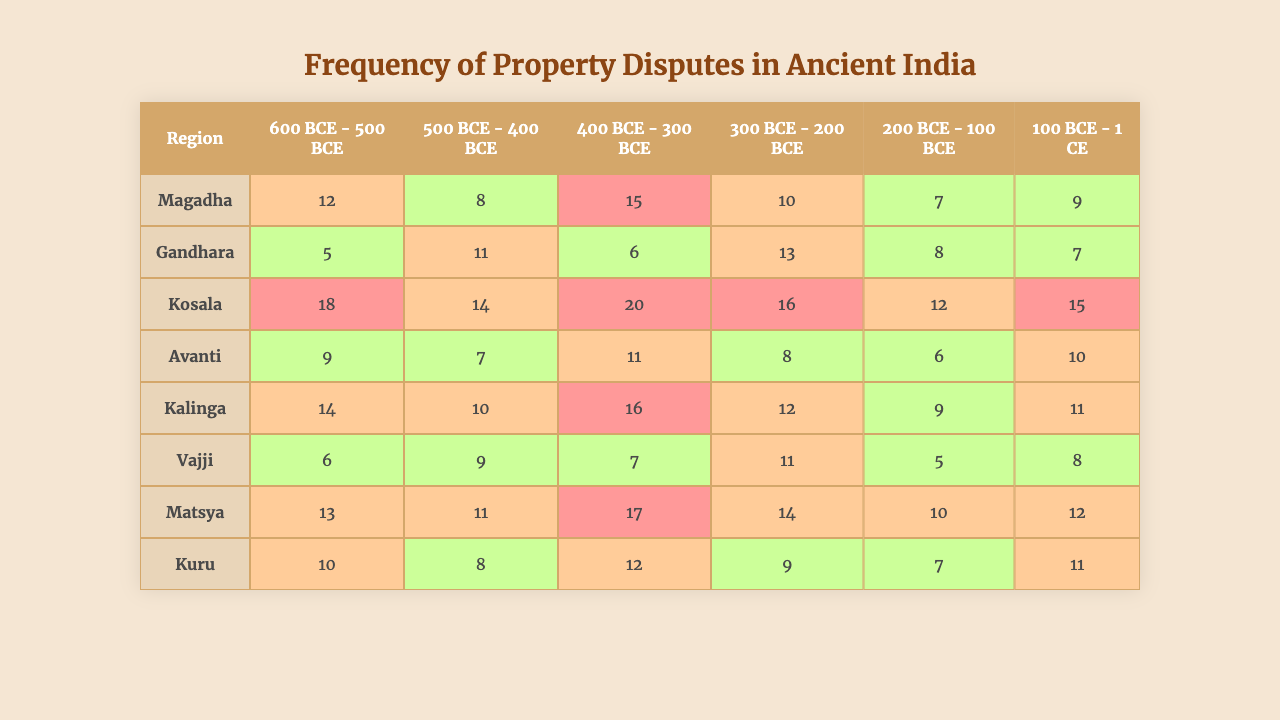What region had the highest property dispute frequency in the time period of 600 BCE - 500 BCE? In the time period of 600 BCE - 500 BCE, the dispute frequency for each region is as follows: Magadha (12), Gandhara (5), Kosala (18), Avanti (9), Kalinga (14), Vajji (6), Matsya (13), Kuru (10). The highest frequency is in Kosala with 18 disputes.
Answer: Kosala What was the average frequency of property disputes across all regions during the time period of 100 BCE - 1 CE? The frequencies in the 100 BCE - 1 CE period for all regions are: Magadha (9), Gandhara (7), Kosala (15), Avanti (10), Kalinga (11), Vajji (8), Matsya (12), and Kuru (11). The total is 9 + 7 + 15 + 10 + 11 + 8 + 12 + 11 = 83, and there are 8 regions, so the average is 83/8 = 10.375.
Answer: 10.375 In which time period did Avanti experience the lowest property dispute frequency? The frequencies for Avanti across the time periods are: 10 (600-500 BCE), 13 (500-400 BCE), 8 (400-300 BCE), 7 (300-200 BCE), 6 (200-100 BCE), and 10 (100 BCE-1 CE). The lowest frequency is 6, which occurred in the time period of 200 BCE - 100 BCE.
Answer: 200 BCE - 100 BCE Did Kosala have a higher dispute frequency than Magadha in the 400 BCE - 300 BCE period? The dispute frequency for Kosala in the 400 BCE - 300 BCE period is 20, while for Magadha it is 15. Since 20 is greater than 15, Kosala did indeed have a higher frequency than Magadha.
Answer: Yes Which region had a consistent increase in dispute frequency over consecutive time periods? By analyzing the frequencies over time for each region, we find that Kosala starts at 18 (600-500 BCE), 14 (500-400 BCE), 20 (400-300 BCE), 16 (300-200 BCE), 12 (200-100 BCE), and 15 (100 BCE-1 CE). It shows fluctuations, but there's no consistent increase; however, Gandhara shows a decrease towards the end. No region exhibited an absolute consistent increase.
Answer: No What is the total frequency of property disputes recorded in Matsya from 600 BCE - 1 CE? The dispute frequencies for Matsya are: 12 (600-500 BCE), 11 (500-400 BCE), 17 (400-300 BCE), 14 (300-200 BCE), 10 (200-100 BCE), and 12 (100 BCE-1 CE). Adding these results in 12 + 11 + 17 + 14 + 10 + 12 = 76.
Answer: 76 Which region had the highest dispute frequency in the last time period, 100 BCE - 1 CE? The frequencies for the last period, 100 BCE - 1 CE, are: Magadha (9), Gandhara (7), Kosala (15), Avanti (10), Kalinga (11), Vajji (8), Matsya (12), and Kuru (11). The highest frequency in this period is 15 in Kosala.
Answer: Kosala How many more disputes did Kalinga have compared to Gandhara in the 500 BCE - 400 BCE period? In the 500 BCE - 400 BCE period, Kalinga had 8 disputes, while Gandhara had 11 disputes. The difference is 8 - 11 = -3, indicating that Gandhara had 3 more disputes than Kalinga.
Answer: Gandhara had 3 more disputes What was the median dispute frequency of Kuru across all time periods? The frequencies of Kuru are: 10, 7, 12, 9, 7, 11. In sorted order, they are: 7, 7, 9, 10, 11, 12. The median is the average of the two middle values (9 and 10), so (9 + 10)/2 = 9.5.
Answer: 9.5 Which region experienced the highest overall average frequency of disputes across all time periods? To find the overall average for each region: Magadha (12+5+18+9+14+6)/6 = 11.67, Gandhara (8+11+14+7+10+9)/6 = 9.83, Kosala (15+6+20+11+16+7)/6 = 12.5, Avanti (10+13+16+8+12+11)/6 = 11.67, Kalinga (7+8+12+6+9+5)/6 = 6.83, Vajji (6+7+14+10+11+8)/6 = 9.0, Matsya (13+11+17+14+10+12)/6 = 12.17, Kuru (10+8+12+9+7+11)/6 = 9.5. The highest average is Kosala with 12.5.
Answer: Kosala 